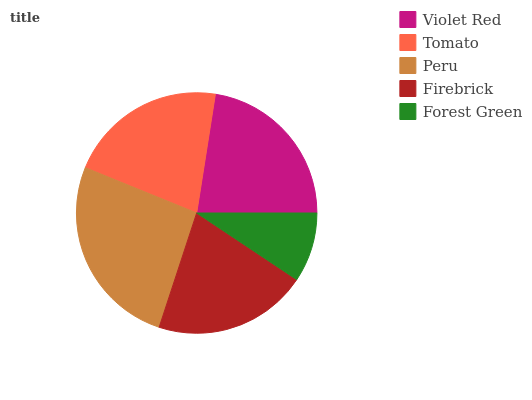Is Forest Green the minimum?
Answer yes or no. Yes. Is Peru the maximum?
Answer yes or no. Yes. Is Tomato the minimum?
Answer yes or no. No. Is Tomato the maximum?
Answer yes or no. No. Is Violet Red greater than Tomato?
Answer yes or no. Yes. Is Tomato less than Violet Red?
Answer yes or no. Yes. Is Tomato greater than Violet Red?
Answer yes or no. No. Is Violet Red less than Tomato?
Answer yes or no. No. Is Tomato the high median?
Answer yes or no. Yes. Is Tomato the low median?
Answer yes or no. Yes. Is Forest Green the high median?
Answer yes or no. No. Is Violet Red the low median?
Answer yes or no. No. 